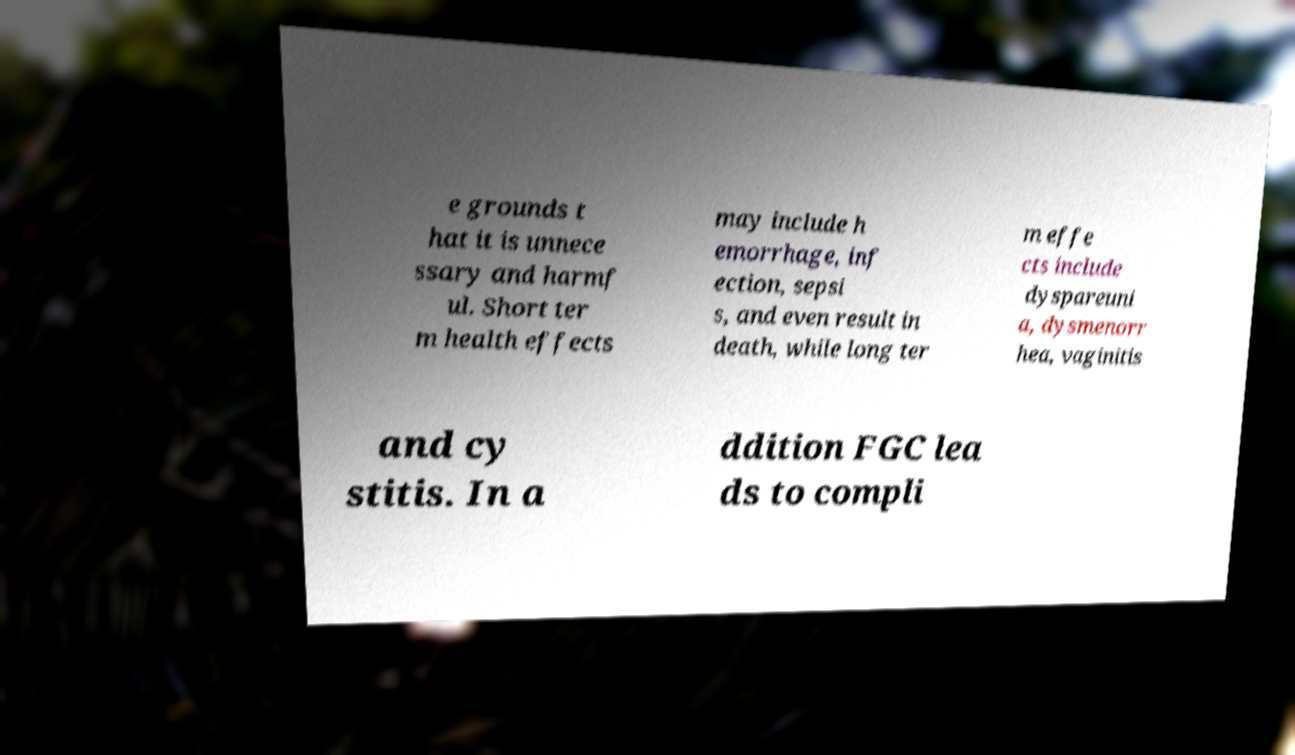Could you assist in decoding the text presented in this image and type it out clearly? e grounds t hat it is unnece ssary and harmf ul. Short ter m health effects may include h emorrhage, inf ection, sepsi s, and even result in death, while long ter m effe cts include dyspareuni a, dysmenorr hea, vaginitis and cy stitis. In a ddition FGC lea ds to compli 